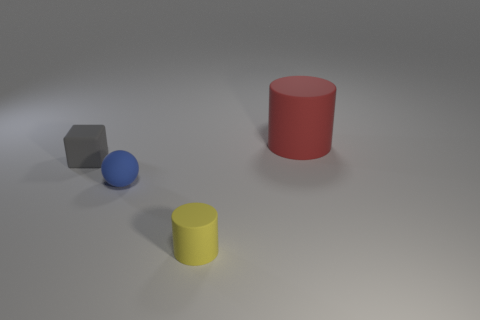Is there any other thing that is the same size as the red rubber cylinder?
Provide a succinct answer. No. Is there anything else that is the same shape as the red rubber thing?
Offer a very short reply. Yes. There is a cylinder right of the cylinder that is in front of the big red matte cylinder on the right side of the small gray rubber object; what color is it?
Offer a terse response. Red. What number of tiny objects are matte cylinders or yellow matte objects?
Your answer should be compact. 1. Are there an equal number of gray objects behind the big red rubber cylinder and tiny blue objects?
Ensure brevity in your answer.  No. Are there any yellow things behind the cube?
Your answer should be compact. No. How many metal things are tiny purple spheres or yellow cylinders?
Your answer should be very brief. 0. There is a tiny gray rubber cube; what number of yellow rubber objects are on the right side of it?
Make the answer very short. 1. Is there a yellow matte thing of the same size as the blue ball?
Give a very brief answer. Yes. Are there any large metallic blocks of the same color as the small ball?
Your answer should be very brief. No. 